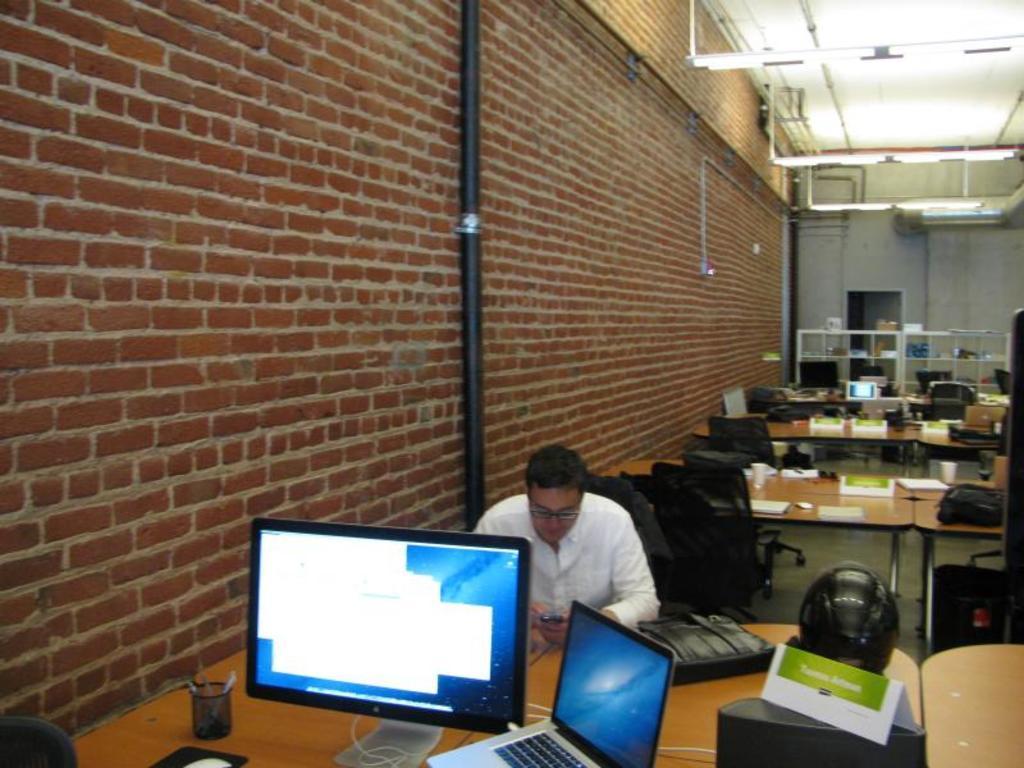Describe this image in one or two sentences. In image is inside the room. There is a person sitting inside and he is holding the phone. There are laptops, computers, bags, helmets, books, mouse on the table. There are lights at the top, there is a pipe on the wall, at the back there is a cupboard. 